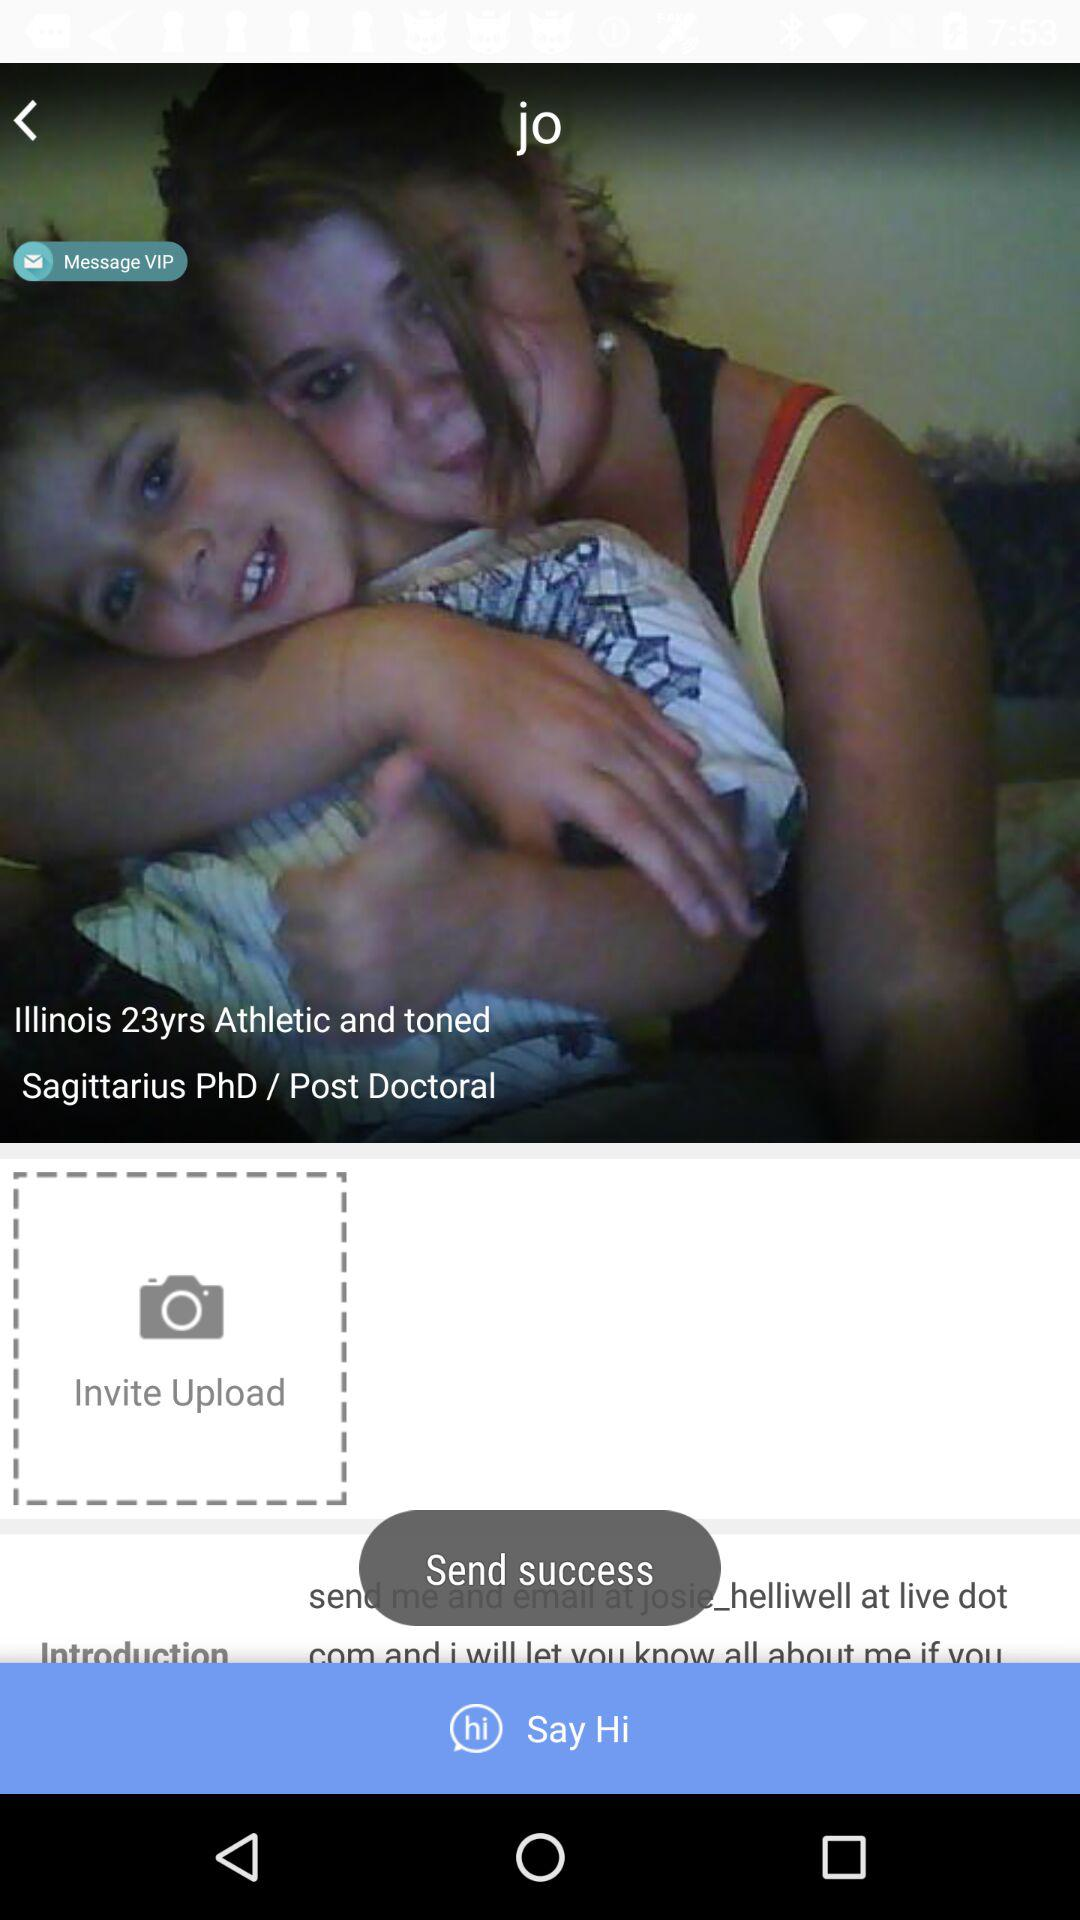Which Illinois city is selected?
When the provided information is insufficient, respond with <no answer>. <no answer> 